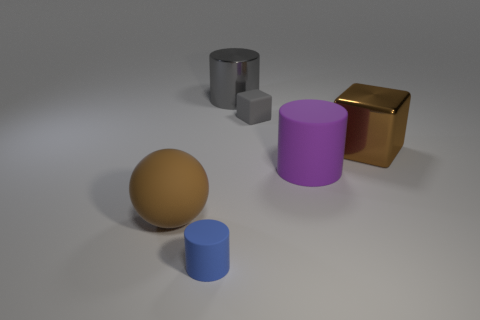Add 4 brown blocks. How many objects exist? 10 Subtract all blocks. How many objects are left? 4 Subtract 0 gray balls. How many objects are left? 6 Subtract all gray blocks. Subtract all blue matte objects. How many objects are left? 4 Add 3 small blue cylinders. How many small blue cylinders are left? 4 Add 3 blue rubber objects. How many blue rubber objects exist? 4 